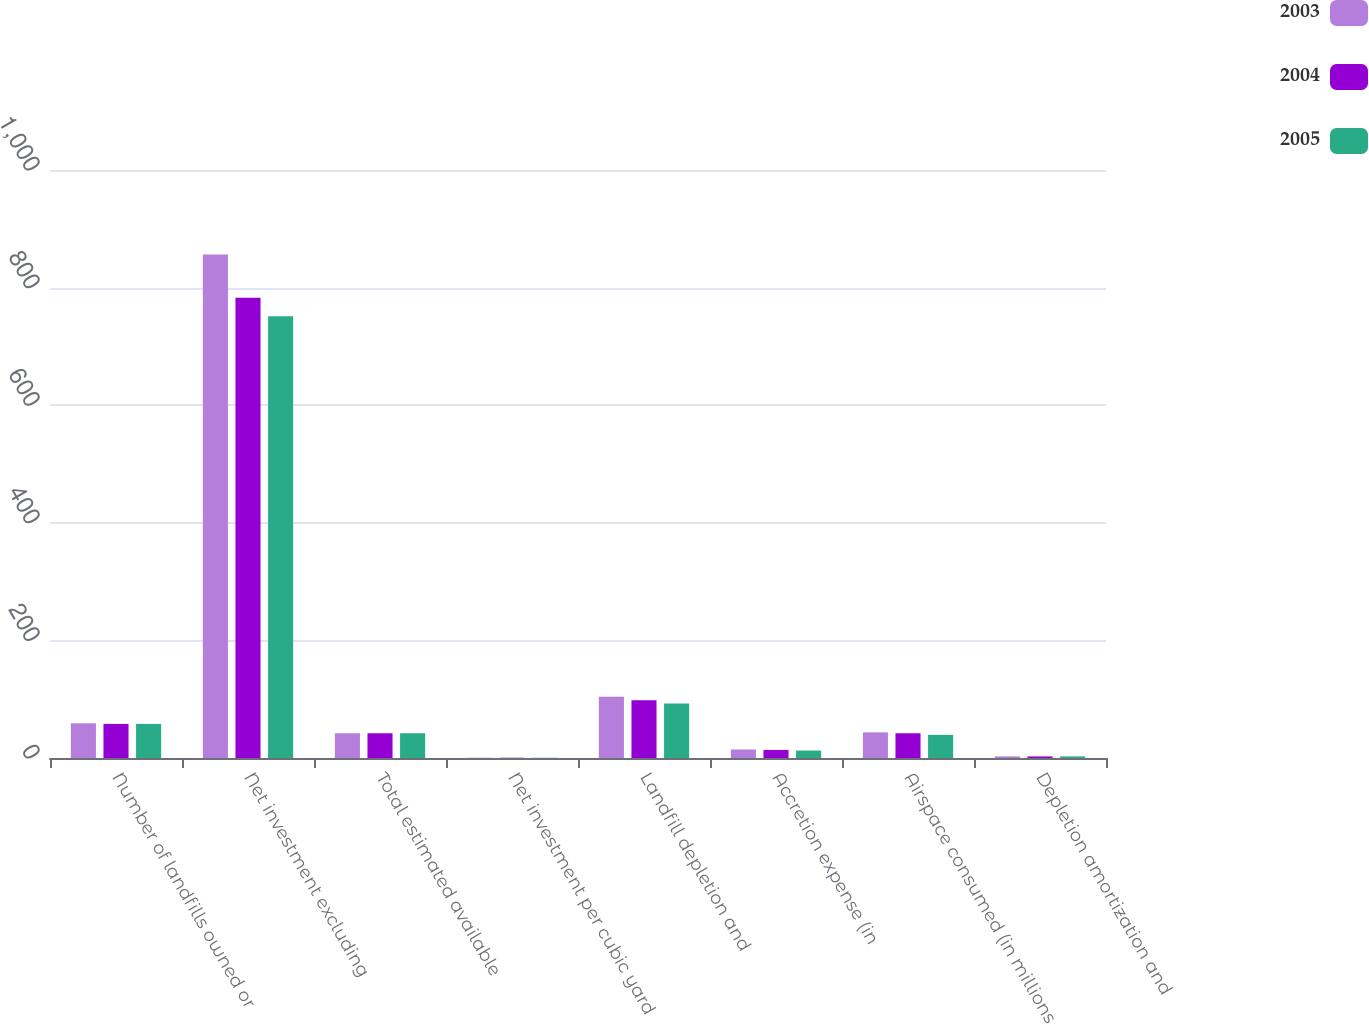Convert chart to OTSL. <chart><loc_0><loc_0><loc_500><loc_500><stacked_bar_chart><ecel><fcel>Number of landfills owned or<fcel>Net investment excluding<fcel>Total estimated available<fcel>Net investment per cubic yard<fcel>Landfill depletion and<fcel>Accretion expense (in<fcel>Airspace consumed (in millions<fcel>Depletion amortization and<nl><fcel>2003<fcel>59<fcel>856.5<fcel>42.1<fcel>0.49<fcel>104.2<fcel>14.5<fcel>43.6<fcel>2.72<nl><fcel>2004<fcel>58<fcel>782.7<fcel>42.1<fcel>0.45<fcel>98.4<fcel>13.7<fcel>42.1<fcel>2.66<nl><fcel>2005<fcel>58<fcel>751.4<fcel>42.1<fcel>0.43<fcel>92.8<fcel>12.7<fcel>39.3<fcel>2.68<nl></chart> 